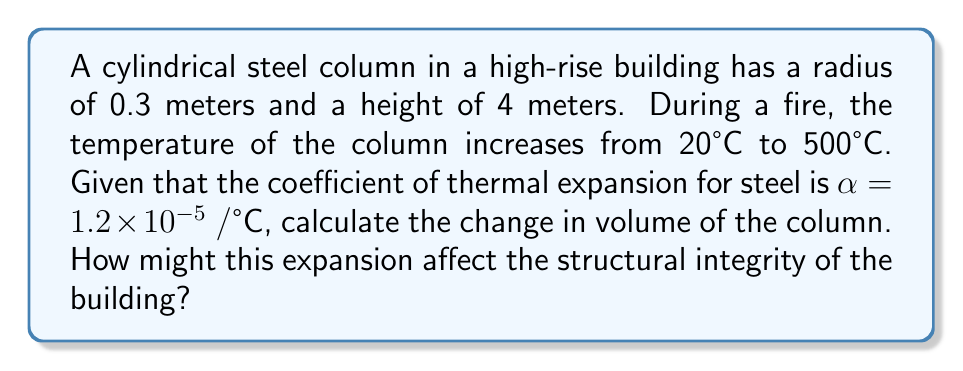Show me your answer to this math problem. To solve this problem, we'll follow these steps:

1. Calculate the initial volume of the column
2. Determine the change in temperature
3. Calculate the volumetric thermal expansion
4. Analyze the impact on structural integrity

Step 1: Initial volume
The volume of a cylinder is given by $V = \pi r^2 h$
$$V_i = \pi (0.3\text{ m})^2 (4\text{ m}) = 1.13097\text{ m}^3$$

Step 2: Change in temperature
$$\Delta T = 500°\text{C} - 20°\text{C} = 480°\text{C}$$

Step 3: Volumetric thermal expansion
The formula for volumetric thermal expansion is:
$$\Delta V = V_i \beta \Delta T$$
where $\beta$ is the volumetric thermal expansion coefficient, which is approximately $3\alpha$ for isotropic materials like steel.

$$\begin{align}
\Delta V &= 1.13097\text{ m}^3 \times (3 \times 1.2 \times 10^{-5} \text{ /°C}) \times 480°\text{C} \\
&= 1.13097 \times 3.6 \times 10^{-5} \times 480 \\
&= 0.019532\text{ m}^3
\end{align}$$

Step 4: Impact on structural integrity
The expansion of 0.019532 m³ represents a 1.73% increase in volume. This expansion can lead to:
1. Increased stress on connecting elements
2. Misalignment of load-bearing components
3. Potential buckling or warping of the column
4. Compromised fire resistance ratings

These factors collectively pose a significant risk to the building's structural integrity during a fire.
Answer: 0.019532 m³; expansion may compromise structural integrity through increased stress, misalignment, and potential buckling. 